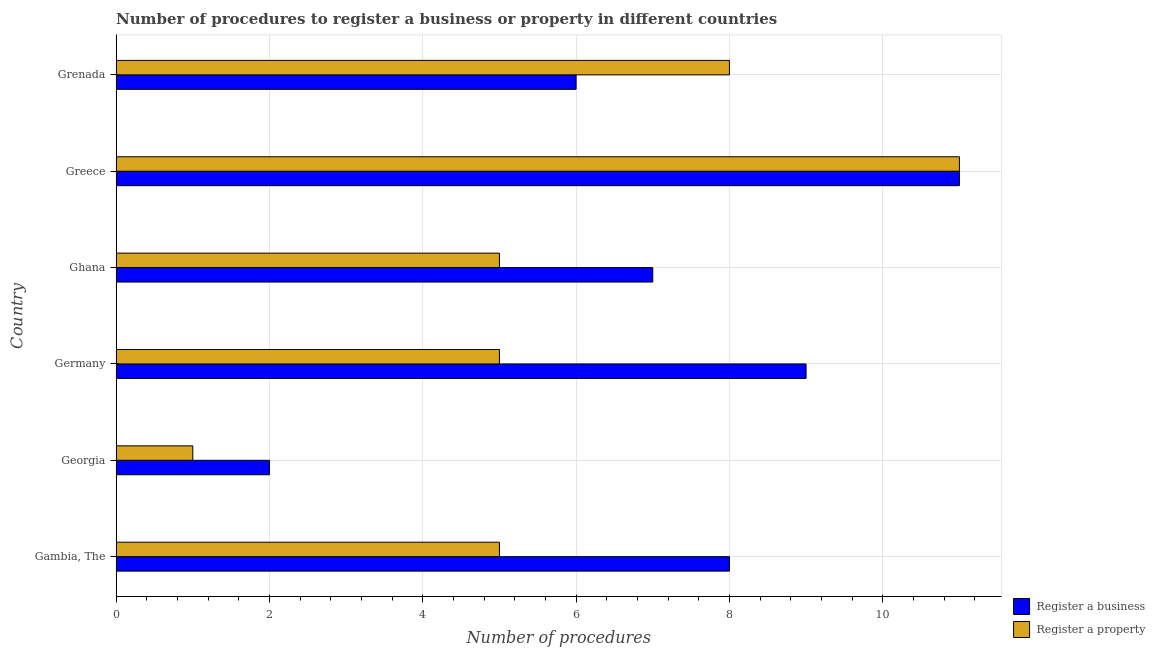How many different coloured bars are there?
Your answer should be compact. 2. How many groups of bars are there?
Offer a terse response. 6. Are the number of bars per tick equal to the number of legend labels?
Your answer should be compact. Yes. How many bars are there on the 5th tick from the top?
Your answer should be very brief. 2. What is the label of the 4th group of bars from the top?
Offer a very short reply. Germany. In how many cases, is the number of bars for a given country not equal to the number of legend labels?
Keep it short and to the point. 0. Across all countries, what is the minimum number of procedures to register a business?
Your answer should be very brief. 2. In which country was the number of procedures to register a business maximum?
Give a very brief answer. Greece. In which country was the number of procedures to register a business minimum?
Your answer should be compact. Georgia. What is the total number of procedures to register a property in the graph?
Your answer should be very brief. 35. What is the difference between the number of procedures to register a business in Ghana and that in Grenada?
Your answer should be very brief. 1. What is the difference between the number of procedures to register a property in Grenada and the number of procedures to register a business in Georgia?
Ensure brevity in your answer.  6. What is the average number of procedures to register a property per country?
Provide a succinct answer. 5.83. In how many countries, is the number of procedures to register a business greater than 5.6 ?
Keep it short and to the point. 5. What is the ratio of the number of procedures to register a property in Gambia, The to that in Grenada?
Offer a terse response. 0.62. Is the difference between the number of procedures to register a business in Ghana and Grenada greater than the difference between the number of procedures to register a property in Ghana and Grenada?
Give a very brief answer. Yes. What is the difference between the highest and the second highest number of procedures to register a business?
Provide a short and direct response. 2. Is the sum of the number of procedures to register a property in Georgia and Ghana greater than the maximum number of procedures to register a business across all countries?
Your answer should be compact. No. What does the 2nd bar from the top in Gambia, The represents?
Your answer should be very brief. Register a business. What does the 2nd bar from the bottom in Grenada represents?
Provide a short and direct response. Register a property. How many bars are there?
Provide a succinct answer. 12. What is the difference between two consecutive major ticks on the X-axis?
Your answer should be very brief. 2. Are the values on the major ticks of X-axis written in scientific E-notation?
Offer a terse response. No. Does the graph contain any zero values?
Your answer should be very brief. No. Where does the legend appear in the graph?
Your answer should be compact. Bottom right. What is the title of the graph?
Make the answer very short. Number of procedures to register a business or property in different countries. Does "current US$" appear as one of the legend labels in the graph?
Your response must be concise. No. What is the label or title of the X-axis?
Offer a terse response. Number of procedures. What is the label or title of the Y-axis?
Make the answer very short. Country. What is the Number of procedures of Register a business in Georgia?
Keep it short and to the point. 2. What is the Number of procedures of Register a business in Germany?
Your answer should be compact. 9. What is the Number of procedures in Register a property in Germany?
Offer a very short reply. 5. What is the Number of procedures in Register a business in Ghana?
Offer a very short reply. 7. What is the Number of procedures in Register a property in Ghana?
Offer a very short reply. 5. What is the Number of procedures of Register a property in Greece?
Provide a succinct answer. 11. What is the Number of procedures in Register a business in Grenada?
Provide a short and direct response. 6. Across all countries, what is the maximum Number of procedures in Register a business?
Offer a very short reply. 11. What is the total Number of procedures of Register a property in the graph?
Give a very brief answer. 35. What is the difference between the Number of procedures of Register a business in Gambia, The and that in Georgia?
Offer a terse response. 6. What is the difference between the Number of procedures of Register a property in Gambia, The and that in Georgia?
Provide a succinct answer. 4. What is the difference between the Number of procedures in Register a business in Gambia, The and that in Germany?
Provide a short and direct response. -1. What is the difference between the Number of procedures in Register a business in Gambia, The and that in Greece?
Give a very brief answer. -3. What is the difference between the Number of procedures in Register a property in Gambia, The and that in Greece?
Provide a short and direct response. -6. What is the difference between the Number of procedures in Register a business in Gambia, The and that in Grenada?
Your answer should be very brief. 2. What is the difference between the Number of procedures of Register a property in Gambia, The and that in Grenada?
Provide a short and direct response. -3. What is the difference between the Number of procedures of Register a business in Georgia and that in Germany?
Give a very brief answer. -7. What is the difference between the Number of procedures in Register a business in Georgia and that in Ghana?
Ensure brevity in your answer.  -5. What is the difference between the Number of procedures in Register a property in Georgia and that in Ghana?
Your response must be concise. -4. What is the difference between the Number of procedures in Register a business in Georgia and that in Greece?
Provide a succinct answer. -9. What is the difference between the Number of procedures in Register a business in Georgia and that in Grenada?
Your answer should be very brief. -4. What is the difference between the Number of procedures of Register a property in Germany and that in Ghana?
Give a very brief answer. 0. What is the difference between the Number of procedures in Register a business in Germany and that in Greece?
Offer a terse response. -2. What is the difference between the Number of procedures in Register a property in Germany and that in Grenada?
Give a very brief answer. -3. What is the difference between the Number of procedures in Register a business in Ghana and that in Greece?
Your response must be concise. -4. What is the difference between the Number of procedures of Register a property in Ghana and that in Greece?
Offer a terse response. -6. What is the difference between the Number of procedures in Register a property in Ghana and that in Grenada?
Your response must be concise. -3. What is the difference between the Number of procedures in Register a business in Gambia, The and the Number of procedures in Register a property in Georgia?
Give a very brief answer. 7. What is the difference between the Number of procedures in Register a business in Gambia, The and the Number of procedures in Register a property in Germany?
Give a very brief answer. 3. What is the difference between the Number of procedures of Register a business in Gambia, The and the Number of procedures of Register a property in Ghana?
Provide a succinct answer. 3. What is the difference between the Number of procedures of Register a business in Georgia and the Number of procedures of Register a property in Germany?
Make the answer very short. -3. What is the difference between the Number of procedures of Register a business in Georgia and the Number of procedures of Register a property in Ghana?
Give a very brief answer. -3. What is the difference between the Number of procedures in Register a business in Georgia and the Number of procedures in Register a property in Greece?
Ensure brevity in your answer.  -9. What is the difference between the Number of procedures of Register a business in Georgia and the Number of procedures of Register a property in Grenada?
Provide a succinct answer. -6. What is the difference between the Number of procedures of Register a business in Germany and the Number of procedures of Register a property in Ghana?
Provide a short and direct response. 4. What is the difference between the Number of procedures of Register a business in Ghana and the Number of procedures of Register a property in Grenada?
Offer a terse response. -1. What is the difference between the Number of procedures in Register a business in Greece and the Number of procedures in Register a property in Grenada?
Your response must be concise. 3. What is the average Number of procedures in Register a business per country?
Your answer should be compact. 7.17. What is the average Number of procedures in Register a property per country?
Provide a succinct answer. 5.83. What is the difference between the Number of procedures of Register a business and Number of procedures of Register a property in Gambia, The?
Your response must be concise. 3. What is the difference between the Number of procedures of Register a business and Number of procedures of Register a property in Germany?
Your response must be concise. 4. What is the difference between the Number of procedures of Register a business and Number of procedures of Register a property in Greece?
Provide a succinct answer. 0. What is the difference between the Number of procedures of Register a business and Number of procedures of Register a property in Grenada?
Make the answer very short. -2. What is the ratio of the Number of procedures in Register a business in Gambia, The to that in Georgia?
Offer a very short reply. 4. What is the ratio of the Number of procedures in Register a property in Gambia, The to that in Georgia?
Make the answer very short. 5. What is the ratio of the Number of procedures of Register a property in Gambia, The to that in Germany?
Make the answer very short. 1. What is the ratio of the Number of procedures of Register a business in Gambia, The to that in Greece?
Give a very brief answer. 0.73. What is the ratio of the Number of procedures of Register a property in Gambia, The to that in Greece?
Make the answer very short. 0.45. What is the ratio of the Number of procedures of Register a business in Gambia, The to that in Grenada?
Your response must be concise. 1.33. What is the ratio of the Number of procedures of Register a business in Georgia to that in Germany?
Make the answer very short. 0.22. What is the ratio of the Number of procedures of Register a property in Georgia to that in Germany?
Provide a short and direct response. 0.2. What is the ratio of the Number of procedures in Register a business in Georgia to that in Ghana?
Your answer should be very brief. 0.29. What is the ratio of the Number of procedures in Register a business in Georgia to that in Greece?
Keep it short and to the point. 0.18. What is the ratio of the Number of procedures in Register a property in Georgia to that in Greece?
Your answer should be very brief. 0.09. What is the ratio of the Number of procedures of Register a business in Georgia to that in Grenada?
Your answer should be compact. 0.33. What is the ratio of the Number of procedures of Register a property in Georgia to that in Grenada?
Keep it short and to the point. 0.12. What is the ratio of the Number of procedures in Register a business in Germany to that in Greece?
Your response must be concise. 0.82. What is the ratio of the Number of procedures of Register a property in Germany to that in Greece?
Provide a succinct answer. 0.45. What is the ratio of the Number of procedures in Register a business in Germany to that in Grenada?
Ensure brevity in your answer.  1.5. What is the ratio of the Number of procedures in Register a business in Ghana to that in Greece?
Provide a short and direct response. 0.64. What is the ratio of the Number of procedures in Register a property in Ghana to that in Greece?
Make the answer very short. 0.45. What is the ratio of the Number of procedures in Register a property in Ghana to that in Grenada?
Give a very brief answer. 0.62. What is the ratio of the Number of procedures in Register a business in Greece to that in Grenada?
Your answer should be very brief. 1.83. What is the ratio of the Number of procedures of Register a property in Greece to that in Grenada?
Keep it short and to the point. 1.38. What is the difference between the highest and the second highest Number of procedures of Register a business?
Ensure brevity in your answer.  2. What is the difference between the highest and the second highest Number of procedures in Register a property?
Give a very brief answer. 3. What is the difference between the highest and the lowest Number of procedures of Register a property?
Your response must be concise. 10. 